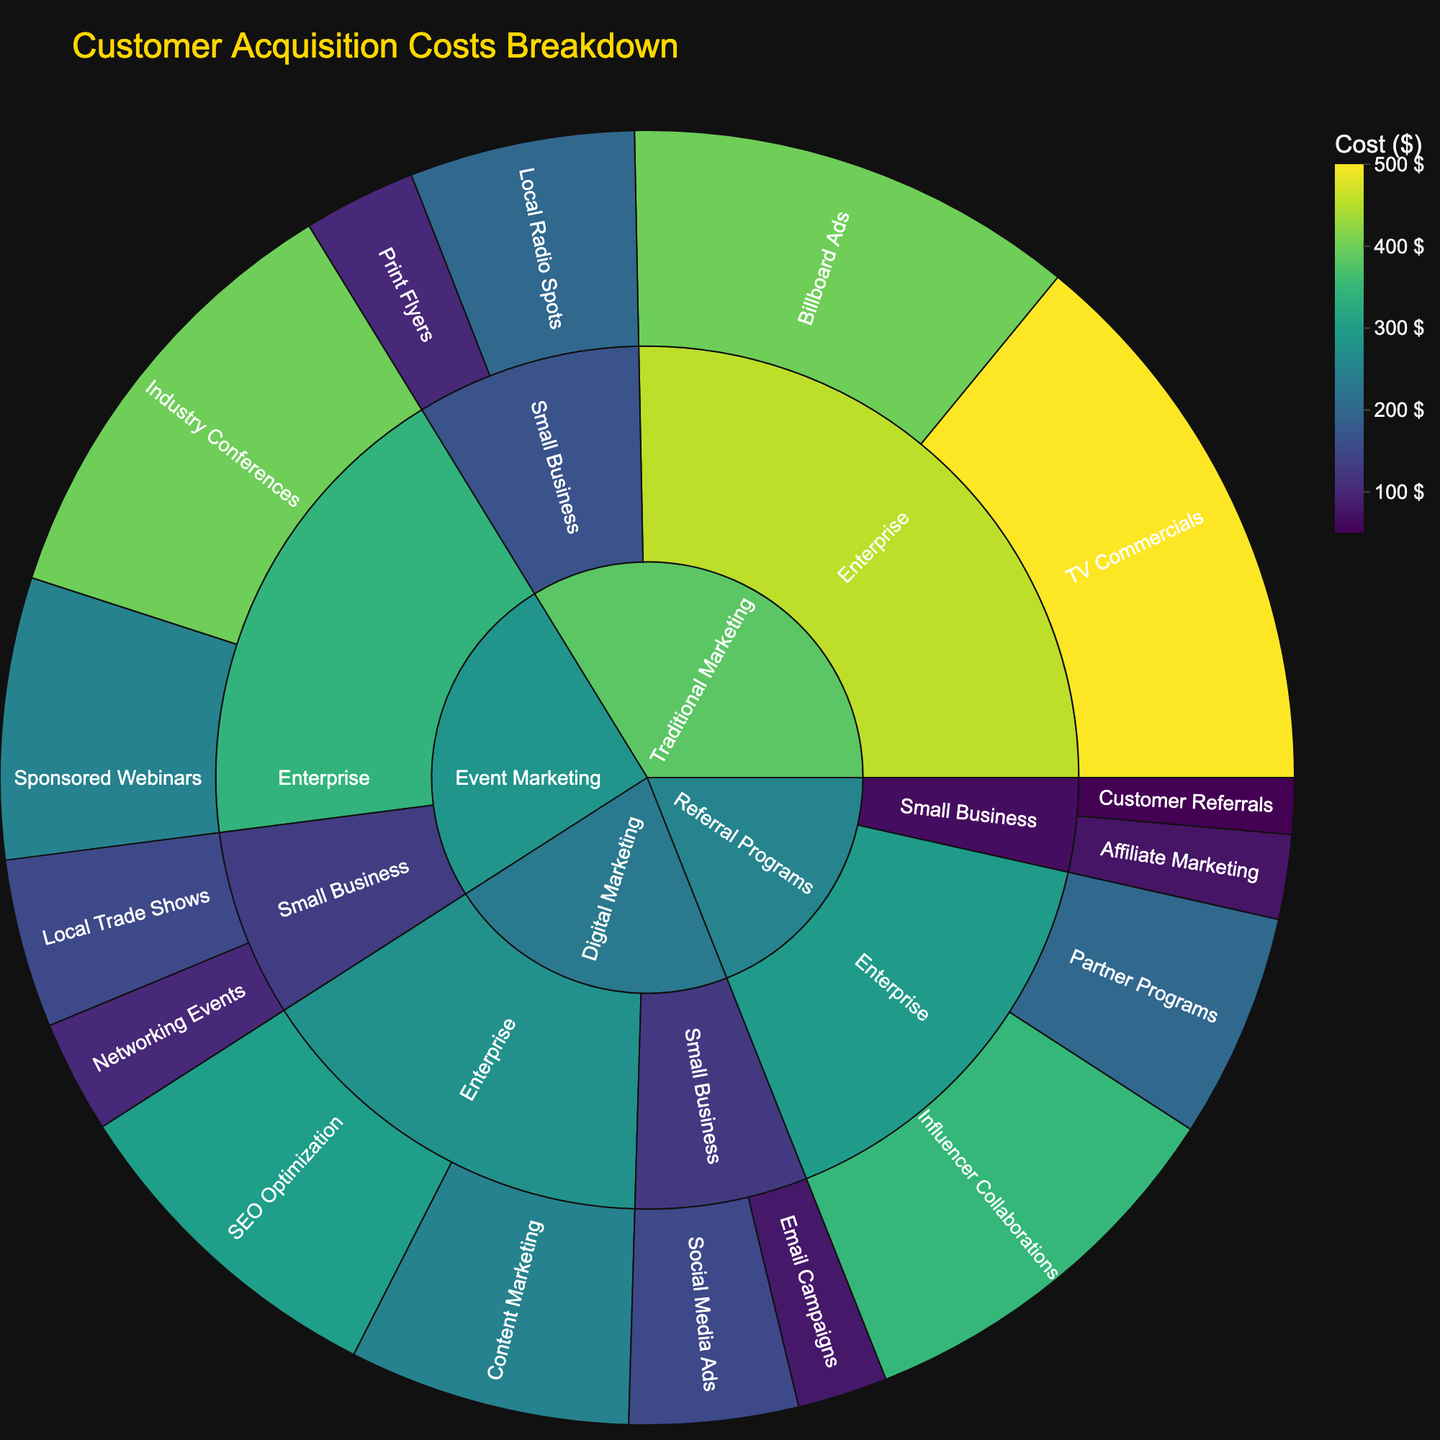What is the title of the plot? The title of the plot is typically displayed at the top of the figure. By examining that area, you can determine the title is visible, and here it reads "Customer Acquisition Costs Breakdown".
Answer: Customer Acquisition Costs Breakdown Which category has the highest overall cost? To determine this, observe the largest outer segment in the sunburst plot, which indicates the highest overall cost. Digital Marketing has the most extensive representation compared to Traditional Marketing, Referral Programs, and Event Marketing.
Answer: Digital Marketing What is the total cost for Traditional Marketing for both Small Business and Enterprise segments? Find all the cost segments under Traditional Marketing, which includes Print Flyers, Local Radio Spots, TV Commercials, and Billboard Ads. Sum up their costs: 100 + 200 + 500 + 400 = 1200.
Answer: 1200 Which product within Digital Marketing for Small Businesses has the highest cost? Within Digital Marketing for Small Business, identify the products (Social Media Ads and Email Campaigns) and compare their costs. Social Media Ads have a higher cost of 150 compared to 80 for Email Campaigns.
Answer: Social Media Ads What is the combined cost of Referral Programs for Enterprises and Small Businesses? Identify the costs for Referral Programs under both segments. For Small Businesses: Customer Referrals (50) and Affiliate Marketing (75). For Enterprises: Partner Programs (200) and Influencer Collaborations (350). Sum them: 50 + 75 + 200 + 350 = 675.
Answer: 675 How does the cost for SEO Optimization in Digital Marketing for Enterprises compare to the cost for TV Commercials in Traditional Marketing for Enterprises? Look at the costs for both SEO Optimization and TV Commercials. SEO Optimization costs 300 while TV Commercials cost 500. Compare these values: 300 < 500.
Answer: Less Which segment in Referral Programs has the highest associated cost product, and what is that product? In the Referral Programs category, compare the products' costs within each segment (Small Business and Enterprise). Influencer Collaborations in the Enterprise segment has the highest cost at 350.
Answer: Enterprise, Influencer Collaborations What is the average cost of marketing strategies for Small Businesses in Digital Marketing? Identify the costs attributed to Small Businesses under Digital Marketing - Social Media Ads (150) and Email Campaigns (80). Calculate their average: (150 + 80) / 2 = 115.
Answer: 115 In which segment does Event Marketing incur the lowest cost, and what is that cost? Look at the costs within Event Marketing for both Small Business and Enterprise segments. Networking Events for Small Business has the lowest cost at 100.
Answer: Small Business, 100 What percentage of the total cost does Content Marketing contribute to within Digital Marketing for Enterprises? Find the cost for Content Marketing (250) and the total cost for Digital Marketing for Enterprises by summing the components (SEO Optimization (300) + Content Marketing (250)) which is 550. Calculate the percentage: (250 / 550) * 100 ≈ 45.45%.
Answer: 45.45% 